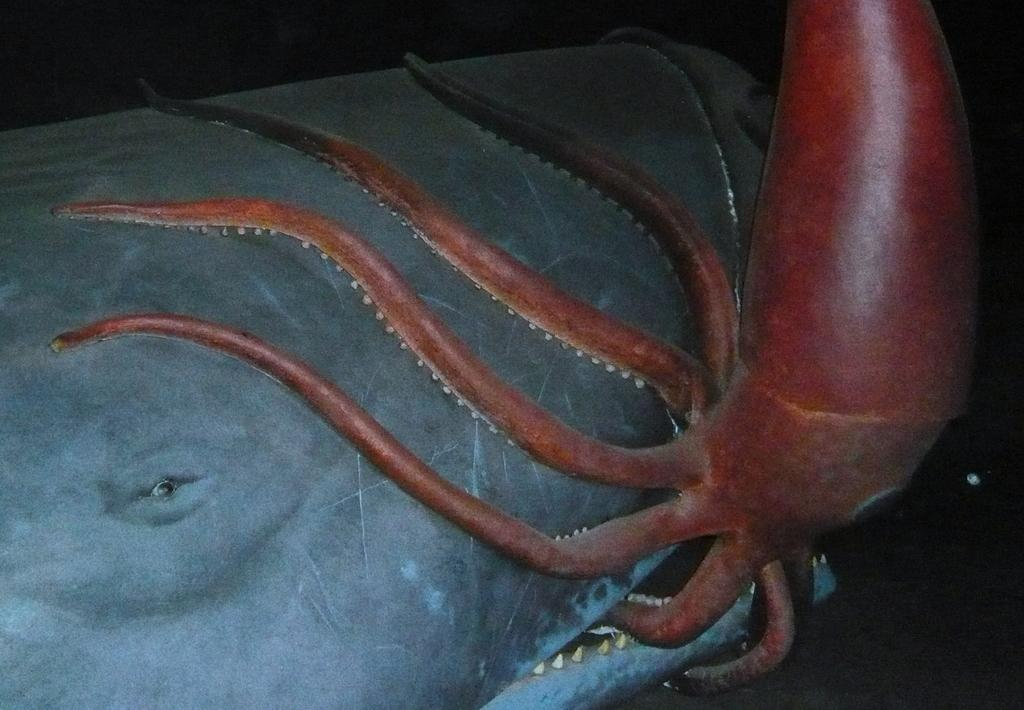What is the main subject of the image? The main subject of the image is a squid. What is the squid doing in the image? The squid appears to be attacking a whale in the image. Can you describe the background of the image? The background of the image is dark. Can you hear the squid laughing while attacking the whale in the image? There is no sound in the image, so it is not possible to determine if the squid is laughing or not. 